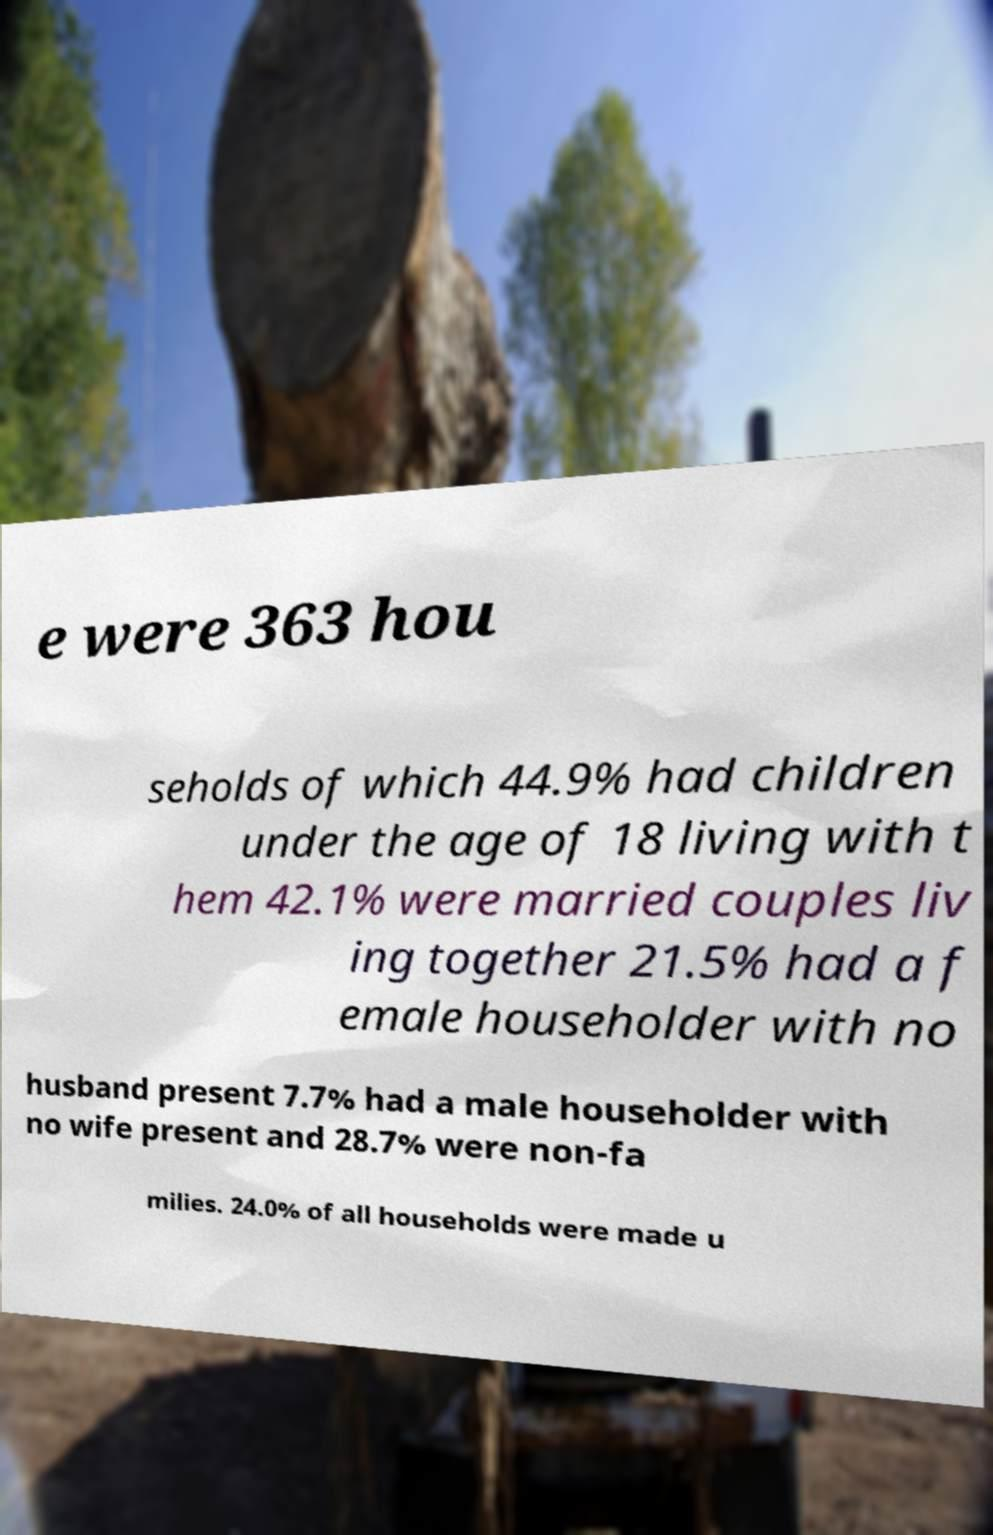Please identify and transcribe the text found in this image. e were 363 hou seholds of which 44.9% had children under the age of 18 living with t hem 42.1% were married couples liv ing together 21.5% had a f emale householder with no husband present 7.7% had a male householder with no wife present and 28.7% were non-fa milies. 24.0% of all households were made u 